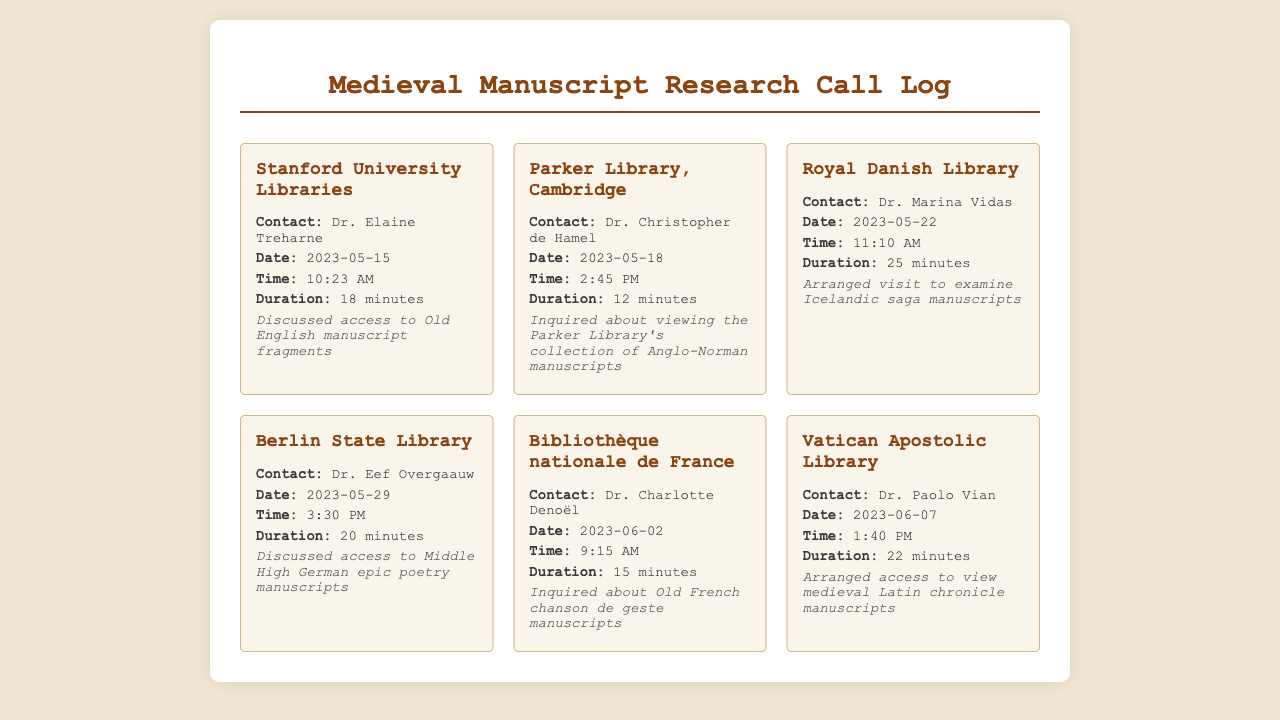what is the name of the contact at Stanford University Libraries? The contact at Stanford University Libraries is Dr. Elaine Treharne.
Answer: Dr. Elaine Treharne what date did you speak with Dr. Christopher de Hamel? The date of the call with Dr. Christopher de Hamel was May 18, 2023.
Answer: May 18, 2023 how long was the call with Dr. Marina Vidas? The duration of the call with Dr. Marina Vidas was 25 minutes.
Answer: 25 minutes which library did you arrange a visit to examine Icelandic saga manuscripts? The library for examining Icelandic saga manuscripts is the Royal Danish Library.
Answer: Royal Danish Library what type of manuscripts were discussed in the call with Dr. Eef Overgaauw? The call with Dr. Eef Overgaauw discussed access to Middle High German epic poetry manuscripts.
Answer: Middle High German epic poetry manuscripts which call had the longest duration? The call with Dr. Marina Vidas had the longest duration at 25 minutes.
Answer: 25 minutes how many calls were made to French libraries? There were two calls made to French libraries, Bibliothèque nationale de France and Vatican Apostolic Library.
Answer: two what is the overall theme of these telephone records? The overall theme is communications regarding access to medieval manuscript repositories.
Answer: access to medieval manuscript repositories who was contacted on June 2, 2023? The contact on June 2, 2023 was Dr. Charlotte Denoël.
Answer: Dr. Charlotte Denoël 